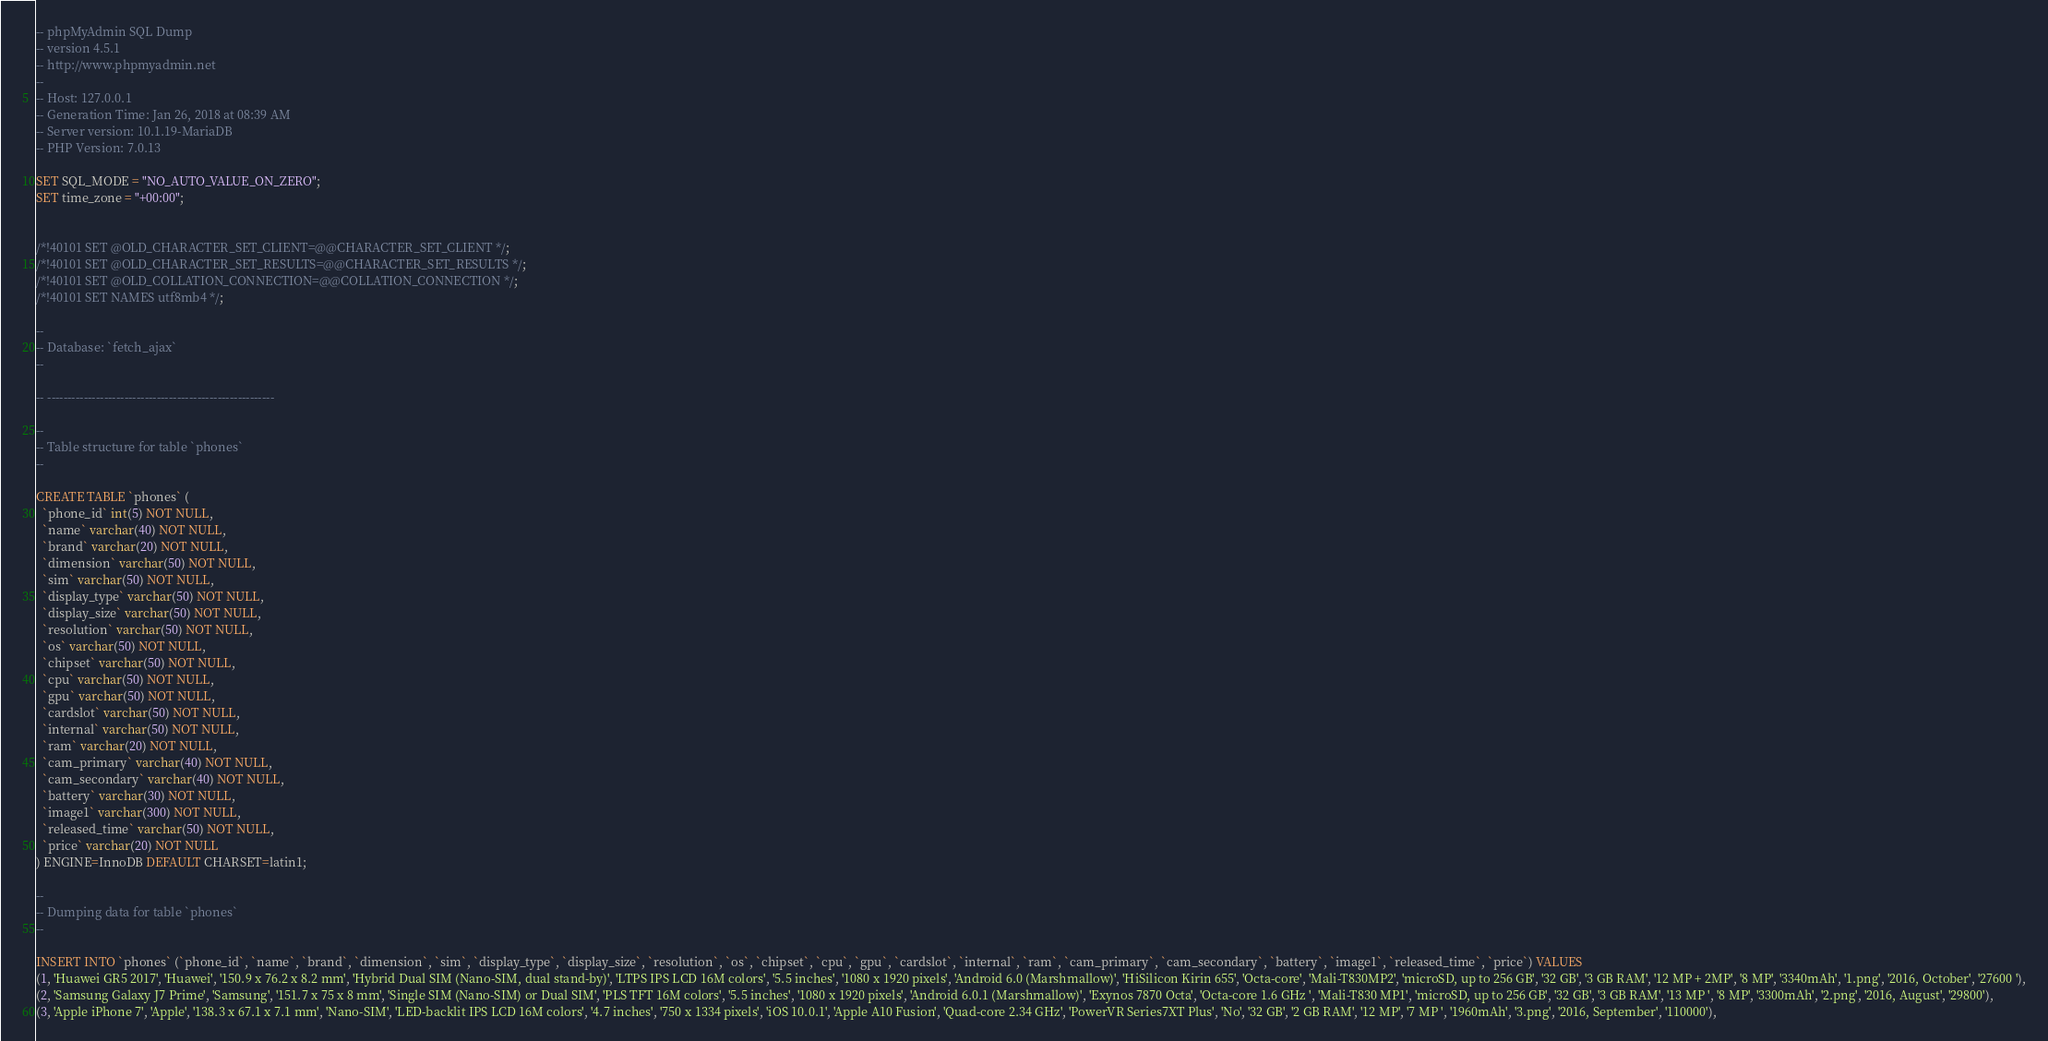Convert code to text. <code><loc_0><loc_0><loc_500><loc_500><_SQL_>-- phpMyAdmin SQL Dump
-- version 4.5.1
-- http://www.phpmyadmin.net
--
-- Host: 127.0.0.1
-- Generation Time: Jan 26, 2018 at 08:39 AM
-- Server version: 10.1.19-MariaDB
-- PHP Version: 7.0.13

SET SQL_MODE = "NO_AUTO_VALUE_ON_ZERO";
SET time_zone = "+00:00";


/*!40101 SET @OLD_CHARACTER_SET_CLIENT=@@CHARACTER_SET_CLIENT */;
/*!40101 SET @OLD_CHARACTER_SET_RESULTS=@@CHARACTER_SET_RESULTS */;
/*!40101 SET @OLD_COLLATION_CONNECTION=@@COLLATION_CONNECTION */;
/*!40101 SET NAMES utf8mb4 */;

--
-- Database: `fetch_ajax`
--

-- --------------------------------------------------------

--
-- Table structure for table `phones`
--

CREATE TABLE `phones` (
  `phone_id` int(5) NOT NULL,
  `name` varchar(40) NOT NULL,
  `brand` varchar(20) NOT NULL,
  `dimension` varchar(50) NOT NULL,
  `sim` varchar(50) NOT NULL,
  `display_type` varchar(50) NOT NULL,
  `display_size` varchar(50) NOT NULL,
  `resolution` varchar(50) NOT NULL,
  `os` varchar(50) NOT NULL,
  `chipset` varchar(50) NOT NULL,
  `cpu` varchar(50) NOT NULL,
  `gpu` varchar(50) NOT NULL,
  `cardslot` varchar(50) NOT NULL,
  `internal` varchar(50) NOT NULL,
  `ram` varchar(20) NOT NULL,
  `cam_primary` varchar(40) NOT NULL,
  `cam_secondary` varchar(40) NOT NULL,
  `battery` varchar(30) NOT NULL,
  `image1` varchar(300) NOT NULL,
  `released_time` varchar(50) NOT NULL,
  `price` varchar(20) NOT NULL
) ENGINE=InnoDB DEFAULT CHARSET=latin1;

--
-- Dumping data for table `phones`
--

INSERT INTO `phones` (`phone_id`, `name`, `brand`, `dimension`, `sim`, `display_type`, `display_size`, `resolution`, `os`, `chipset`, `cpu`, `gpu`, `cardslot`, `internal`, `ram`, `cam_primary`, `cam_secondary`, `battery`, `image1`, `released_time`, `price`) VALUES
(1, 'Huawei GR5 2017', 'Huawei', '150.9 x 76.2 x 8.2 mm', 'Hybrid Dual SIM (Nano-SIM, dual stand-by)', 'LTPS IPS LCD 16M colors', '5.5 inches', '1080 x 1920 pixels', 'Android 6.0 (Marshmallow)', 'HiSilicon Kirin 655', 'Octa-core', 'Mali-T830MP2', 'microSD, up to 256 GB', '32 GB', '3 GB RAM', '12 MP + 2MP', '8 MP', '3340mAh', '1.png', '2016, October', '27600 '),
(2, 'Samsung Galaxy J7 Prime', 'Samsung', '151.7 x 75 x 8 mm', 'Single SIM (Nano-SIM) or Dual SIM', 'PLS TFT 16M colors', '5.5 inches', '1080 x 1920 pixels', 'Android 6.0.1 (Marshmallow)', 'Exynos 7870 Octa', 'Octa-core 1.6 GHz ', 'Mali-T830 MP1', 'microSD, up to 256 GB', '32 GB', '3 GB RAM', '13 MP ', '8 MP', '3300mAh', '2.png', '2016, August', '29800'),
(3, 'Apple iPhone 7', 'Apple', '138.3 x 67.1 x 7.1 mm', 'Nano-SIM', 'LED-backlit IPS LCD 16M colors', '4.7 inches', '750 x 1334 pixels', 'iOS 10.0.1', 'Apple A10 Fusion', 'Quad-core 2.34 GHz', 'PowerVR Series7XT Plus', 'No', '32 GB', '2 GB RAM', '12 MP', '7 MP ', '1960mAh', '3.png', '2016, September', '110000'),</code> 